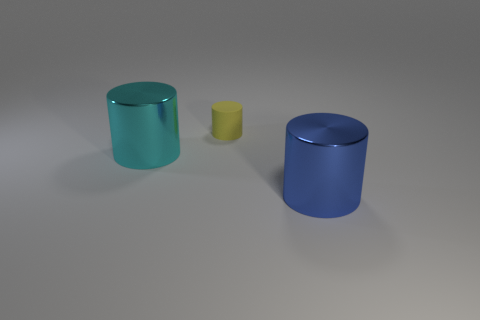How would you describe the lighting and shadows in this scene? The lighting in the scene is diffused and soft, casting gentle shadows to the right of the objects, indicating that the light source is coming from the upper left. This creates a calm and quiet atmosphere with subtle gradations on the objects' surfaces. 